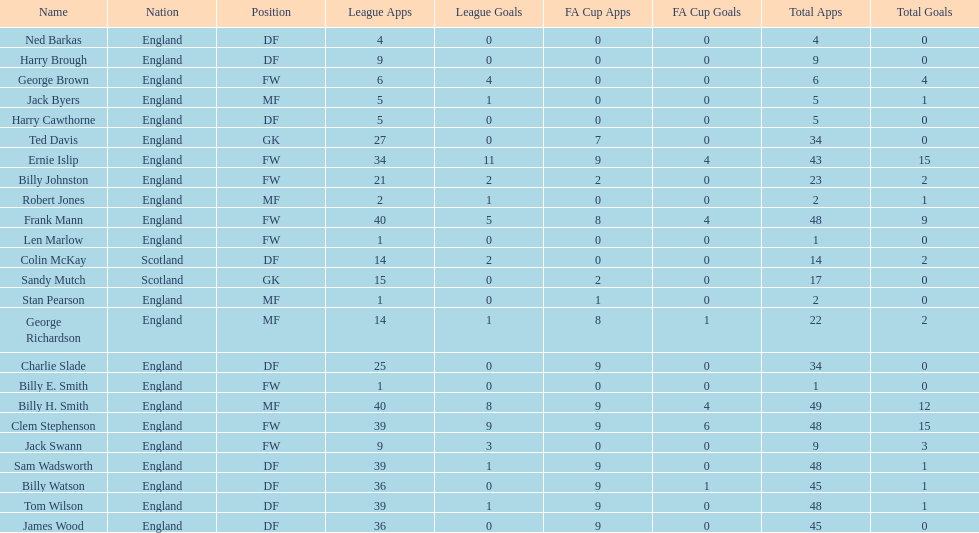How many league applications does ted davis have? 27. 